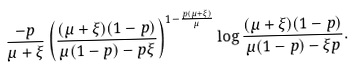Convert formula to latex. <formula><loc_0><loc_0><loc_500><loc_500>\frac { - p } { \mu + \xi } \left ( \frac { ( \mu + \xi ) ( 1 - p ) } { \mu ( 1 - p ) - p \xi } \right ) ^ { 1 - \frac { p ( \mu + \xi ) } { \mu } } \log \frac { ( \mu + \xi ) ( 1 - p ) } { \mu ( 1 - p ) - \xi p } .</formula> 